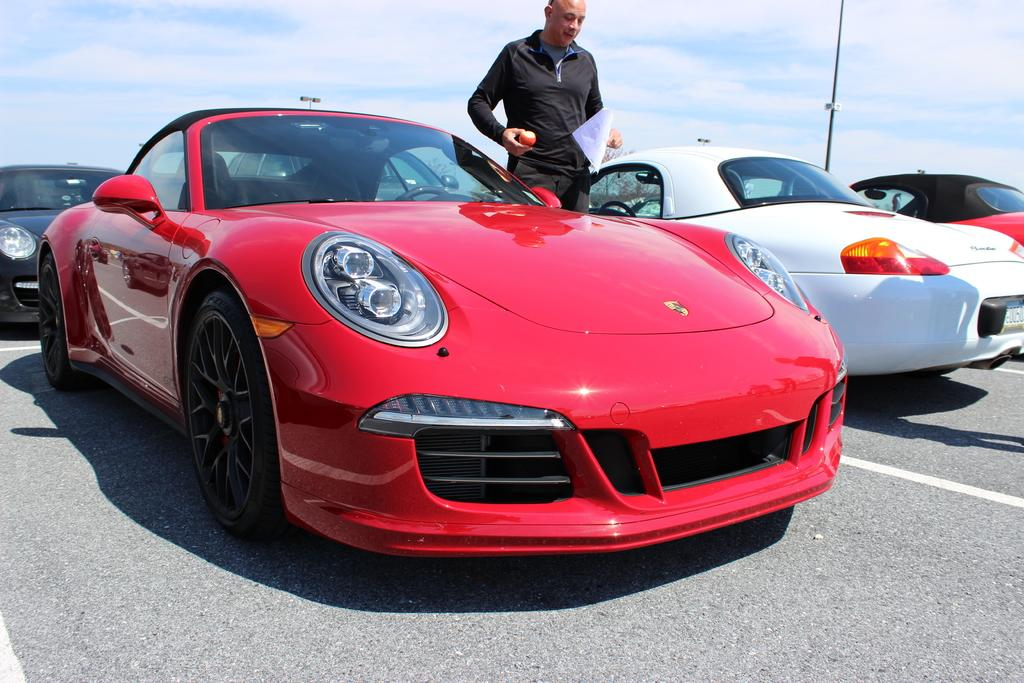What type of vehicles can be seen in the image? There are cars in the image. Can you describe the person in the image? The person is wearing a black dress and is holding a paper and a fruit. What is the person doing with the paper and fruit? The person is holding a paper and a fruit, but their actions with these items are not clear from the image. What is visible in the background of the image? There is a pole in the background of the image. What is visible at the top of the image? The sky is visible at the top of the image. How many jellyfish are swimming in the sky in the image? There are no jellyfish present in the image, and the sky is visible, not a body of water where jellyfish would be found. 